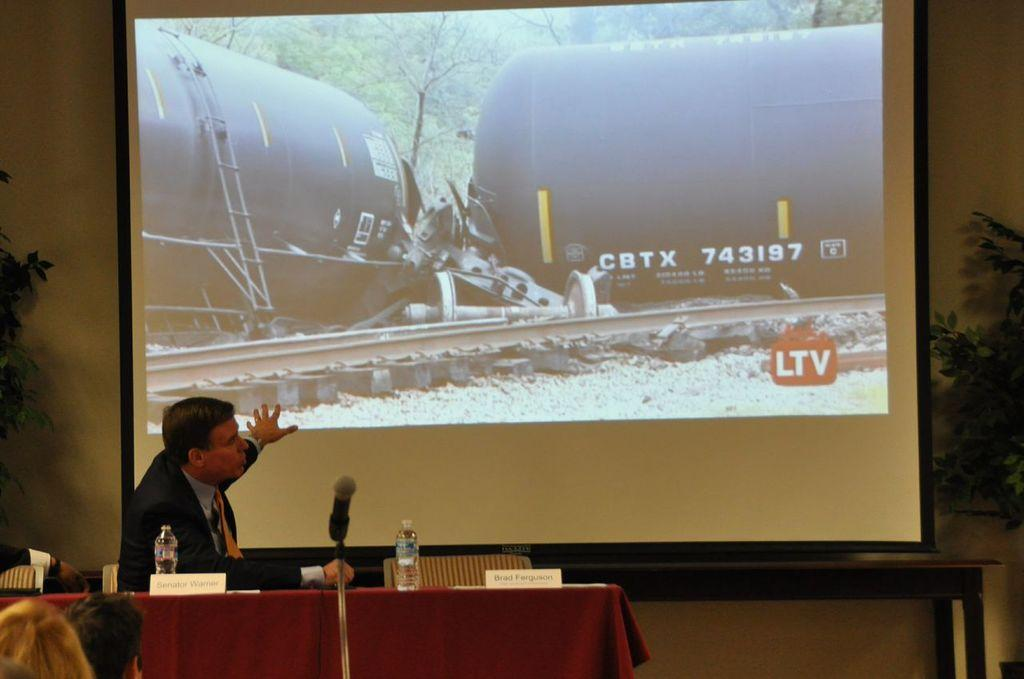<image>
Summarize the visual content of the image. A man pointing to a projection of a derailed train with the letters CBTX. 